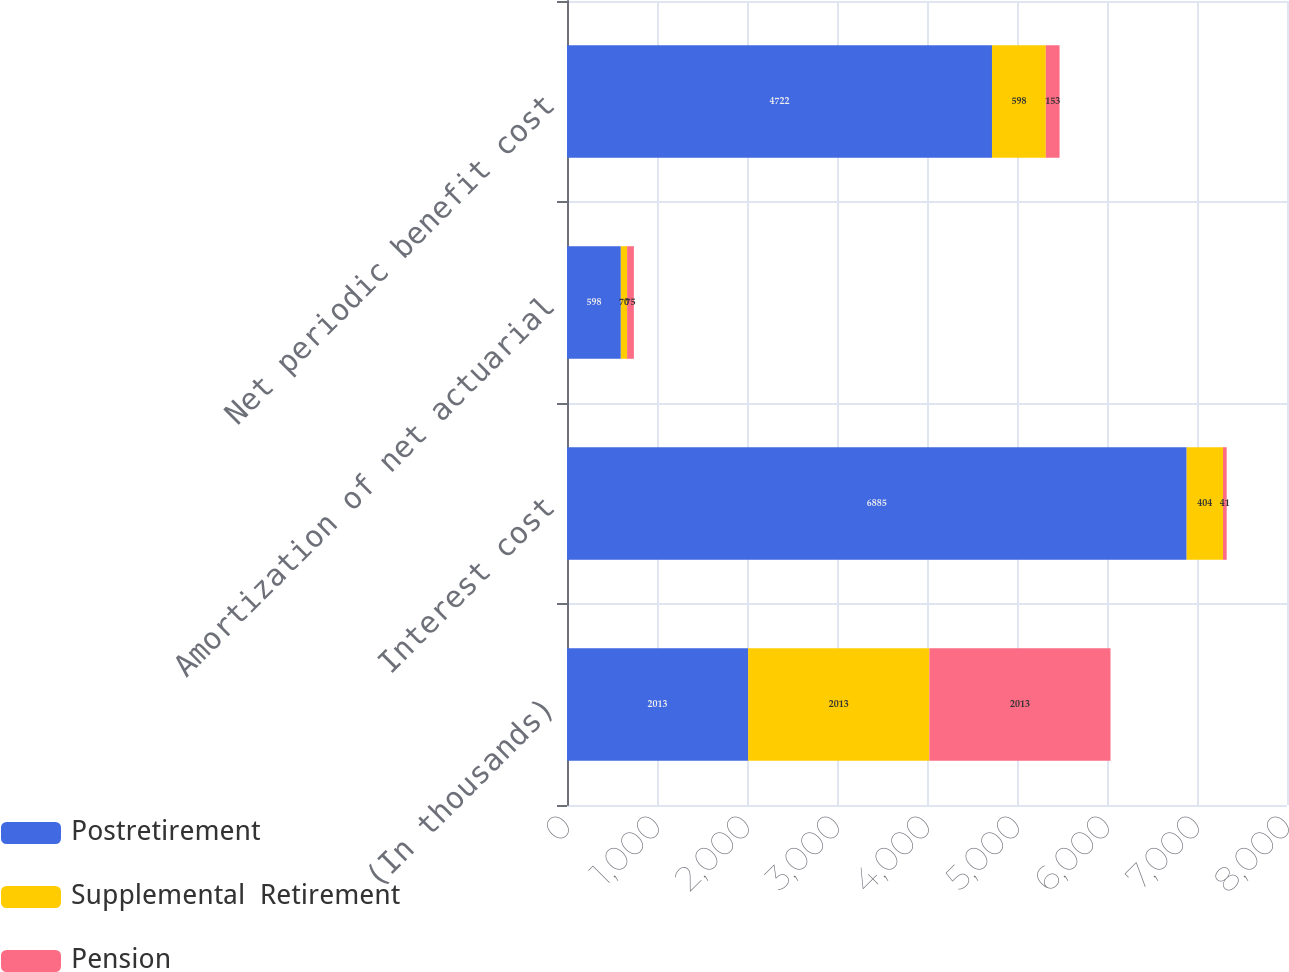Convert chart to OTSL. <chart><loc_0><loc_0><loc_500><loc_500><stacked_bar_chart><ecel><fcel>(In thousands)<fcel>Interest cost<fcel>Amortization of net actuarial<fcel>Net periodic benefit cost<nl><fcel>Postretirement<fcel>2013<fcel>6885<fcel>598<fcel>4722<nl><fcel>Supplemental  Retirement<fcel>2013<fcel>404<fcel>70<fcel>598<nl><fcel>Pension<fcel>2013<fcel>41<fcel>75<fcel>153<nl></chart> 